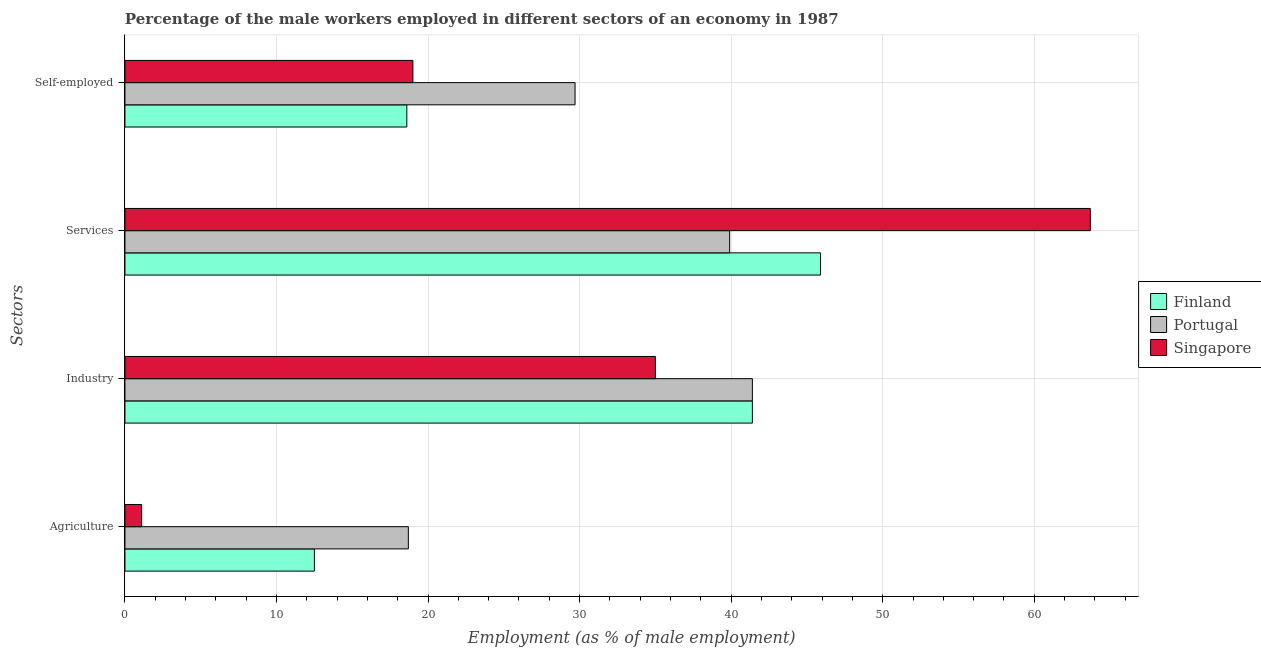Are the number of bars per tick equal to the number of legend labels?
Your answer should be compact. Yes. Are the number of bars on each tick of the Y-axis equal?
Offer a terse response. Yes. What is the label of the 4th group of bars from the top?
Keep it short and to the point. Agriculture. What is the percentage of male workers in agriculture in Portugal?
Your answer should be compact. 18.7. Across all countries, what is the maximum percentage of male workers in agriculture?
Offer a terse response. 18.7. Across all countries, what is the minimum percentage of male workers in services?
Offer a very short reply. 39.9. In which country was the percentage of self employed male workers maximum?
Ensure brevity in your answer.  Portugal. What is the total percentage of male workers in industry in the graph?
Give a very brief answer. 117.8. What is the difference between the percentage of male workers in industry in Finland and that in Portugal?
Your answer should be compact. 0. What is the difference between the percentage of male workers in industry in Singapore and the percentage of male workers in agriculture in Finland?
Your response must be concise. 22.5. What is the average percentage of self employed male workers per country?
Provide a succinct answer. 22.43. What is the difference between the percentage of male workers in agriculture and percentage of male workers in industry in Portugal?
Keep it short and to the point. -22.7. What is the ratio of the percentage of male workers in agriculture in Singapore to that in Portugal?
Your answer should be compact. 0.06. Is the percentage of self employed male workers in Finland less than that in Portugal?
Your answer should be very brief. Yes. What is the difference between the highest and the second highest percentage of male workers in industry?
Offer a very short reply. 0. What is the difference between the highest and the lowest percentage of male workers in industry?
Offer a terse response. 6.4. What does the 1st bar from the top in Self-employed represents?
Keep it short and to the point. Singapore. What does the 1st bar from the bottom in Services represents?
Make the answer very short. Finland. Is it the case that in every country, the sum of the percentage of male workers in agriculture and percentage of male workers in industry is greater than the percentage of male workers in services?
Your answer should be very brief. No. How many bars are there?
Offer a very short reply. 12. What is the difference between two consecutive major ticks on the X-axis?
Keep it short and to the point. 10. Are the values on the major ticks of X-axis written in scientific E-notation?
Your answer should be compact. No. How are the legend labels stacked?
Your answer should be very brief. Vertical. What is the title of the graph?
Give a very brief answer. Percentage of the male workers employed in different sectors of an economy in 1987. What is the label or title of the X-axis?
Offer a terse response. Employment (as % of male employment). What is the label or title of the Y-axis?
Your answer should be compact. Sectors. What is the Employment (as % of male employment) in Portugal in Agriculture?
Make the answer very short. 18.7. What is the Employment (as % of male employment) in Singapore in Agriculture?
Provide a succinct answer. 1.1. What is the Employment (as % of male employment) in Finland in Industry?
Offer a very short reply. 41.4. What is the Employment (as % of male employment) of Portugal in Industry?
Provide a short and direct response. 41.4. What is the Employment (as % of male employment) of Finland in Services?
Offer a terse response. 45.9. What is the Employment (as % of male employment) of Portugal in Services?
Give a very brief answer. 39.9. What is the Employment (as % of male employment) of Singapore in Services?
Your answer should be very brief. 63.7. What is the Employment (as % of male employment) of Finland in Self-employed?
Keep it short and to the point. 18.6. What is the Employment (as % of male employment) in Portugal in Self-employed?
Provide a short and direct response. 29.7. Across all Sectors, what is the maximum Employment (as % of male employment) in Finland?
Offer a terse response. 45.9. Across all Sectors, what is the maximum Employment (as % of male employment) of Portugal?
Provide a succinct answer. 41.4. Across all Sectors, what is the maximum Employment (as % of male employment) in Singapore?
Ensure brevity in your answer.  63.7. Across all Sectors, what is the minimum Employment (as % of male employment) of Portugal?
Make the answer very short. 18.7. Across all Sectors, what is the minimum Employment (as % of male employment) of Singapore?
Offer a terse response. 1.1. What is the total Employment (as % of male employment) of Finland in the graph?
Offer a very short reply. 118.4. What is the total Employment (as % of male employment) in Portugal in the graph?
Provide a short and direct response. 129.7. What is the total Employment (as % of male employment) of Singapore in the graph?
Ensure brevity in your answer.  118.8. What is the difference between the Employment (as % of male employment) of Finland in Agriculture and that in Industry?
Your answer should be compact. -28.9. What is the difference between the Employment (as % of male employment) of Portugal in Agriculture and that in Industry?
Ensure brevity in your answer.  -22.7. What is the difference between the Employment (as % of male employment) of Singapore in Agriculture and that in Industry?
Make the answer very short. -33.9. What is the difference between the Employment (as % of male employment) of Finland in Agriculture and that in Services?
Offer a very short reply. -33.4. What is the difference between the Employment (as % of male employment) of Portugal in Agriculture and that in Services?
Keep it short and to the point. -21.2. What is the difference between the Employment (as % of male employment) in Singapore in Agriculture and that in Services?
Provide a short and direct response. -62.6. What is the difference between the Employment (as % of male employment) of Finland in Agriculture and that in Self-employed?
Your response must be concise. -6.1. What is the difference between the Employment (as % of male employment) of Singapore in Agriculture and that in Self-employed?
Give a very brief answer. -17.9. What is the difference between the Employment (as % of male employment) of Singapore in Industry and that in Services?
Your answer should be very brief. -28.7. What is the difference between the Employment (as % of male employment) in Finland in Industry and that in Self-employed?
Your response must be concise. 22.8. What is the difference between the Employment (as % of male employment) of Singapore in Industry and that in Self-employed?
Keep it short and to the point. 16. What is the difference between the Employment (as % of male employment) of Finland in Services and that in Self-employed?
Offer a very short reply. 27.3. What is the difference between the Employment (as % of male employment) in Portugal in Services and that in Self-employed?
Your answer should be very brief. 10.2. What is the difference between the Employment (as % of male employment) in Singapore in Services and that in Self-employed?
Keep it short and to the point. 44.7. What is the difference between the Employment (as % of male employment) of Finland in Agriculture and the Employment (as % of male employment) of Portugal in Industry?
Make the answer very short. -28.9. What is the difference between the Employment (as % of male employment) in Finland in Agriculture and the Employment (as % of male employment) in Singapore in Industry?
Your response must be concise. -22.5. What is the difference between the Employment (as % of male employment) of Portugal in Agriculture and the Employment (as % of male employment) of Singapore in Industry?
Offer a very short reply. -16.3. What is the difference between the Employment (as % of male employment) in Finland in Agriculture and the Employment (as % of male employment) in Portugal in Services?
Provide a succinct answer. -27.4. What is the difference between the Employment (as % of male employment) in Finland in Agriculture and the Employment (as % of male employment) in Singapore in Services?
Keep it short and to the point. -51.2. What is the difference between the Employment (as % of male employment) in Portugal in Agriculture and the Employment (as % of male employment) in Singapore in Services?
Offer a very short reply. -45. What is the difference between the Employment (as % of male employment) in Finland in Agriculture and the Employment (as % of male employment) in Portugal in Self-employed?
Offer a very short reply. -17.2. What is the difference between the Employment (as % of male employment) in Finland in Industry and the Employment (as % of male employment) in Portugal in Services?
Your answer should be very brief. 1.5. What is the difference between the Employment (as % of male employment) in Finland in Industry and the Employment (as % of male employment) in Singapore in Services?
Your answer should be compact. -22.3. What is the difference between the Employment (as % of male employment) in Portugal in Industry and the Employment (as % of male employment) in Singapore in Services?
Give a very brief answer. -22.3. What is the difference between the Employment (as % of male employment) in Finland in Industry and the Employment (as % of male employment) in Singapore in Self-employed?
Ensure brevity in your answer.  22.4. What is the difference between the Employment (as % of male employment) of Portugal in Industry and the Employment (as % of male employment) of Singapore in Self-employed?
Provide a succinct answer. 22.4. What is the difference between the Employment (as % of male employment) in Finland in Services and the Employment (as % of male employment) in Singapore in Self-employed?
Ensure brevity in your answer.  26.9. What is the difference between the Employment (as % of male employment) in Portugal in Services and the Employment (as % of male employment) in Singapore in Self-employed?
Make the answer very short. 20.9. What is the average Employment (as % of male employment) in Finland per Sectors?
Provide a succinct answer. 29.6. What is the average Employment (as % of male employment) in Portugal per Sectors?
Your answer should be compact. 32.42. What is the average Employment (as % of male employment) of Singapore per Sectors?
Offer a terse response. 29.7. What is the difference between the Employment (as % of male employment) in Finland and Employment (as % of male employment) in Portugal in Agriculture?
Your answer should be very brief. -6.2. What is the difference between the Employment (as % of male employment) in Finland and Employment (as % of male employment) in Singapore in Agriculture?
Provide a short and direct response. 11.4. What is the difference between the Employment (as % of male employment) in Portugal and Employment (as % of male employment) in Singapore in Agriculture?
Ensure brevity in your answer.  17.6. What is the difference between the Employment (as % of male employment) of Finland and Employment (as % of male employment) of Portugal in Industry?
Make the answer very short. 0. What is the difference between the Employment (as % of male employment) in Portugal and Employment (as % of male employment) in Singapore in Industry?
Keep it short and to the point. 6.4. What is the difference between the Employment (as % of male employment) in Finland and Employment (as % of male employment) in Singapore in Services?
Keep it short and to the point. -17.8. What is the difference between the Employment (as % of male employment) in Portugal and Employment (as % of male employment) in Singapore in Services?
Offer a very short reply. -23.8. What is the difference between the Employment (as % of male employment) in Finland and Employment (as % of male employment) in Portugal in Self-employed?
Ensure brevity in your answer.  -11.1. What is the difference between the Employment (as % of male employment) in Finland and Employment (as % of male employment) in Singapore in Self-employed?
Ensure brevity in your answer.  -0.4. What is the ratio of the Employment (as % of male employment) of Finland in Agriculture to that in Industry?
Ensure brevity in your answer.  0.3. What is the ratio of the Employment (as % of male employment) in Portugal in Agriculture to that in Industry?
Provide a succinct answer. 0.45. What is the ratio of the Employment (as % of male employment) in Singapore in Agriculture to that in Industry?
Ensure brevity in your answer.  0.03. What is the ratio of the Employment (as % of male employment) of Finland in Agriculture to that in Services?
Your answer should be compact. 0.27. What is the ratio of the Employment (as % of male employment) of Portugal in Agriculture to that in Services?
Ensure brevity in your answer.  0.47. What is the ratio of the Employment (as % of male employment) of Singapore in Agriculture to that in Services?
Keep it short and to the point. 0.02. What is the ratio of the Employment (as % of male employment) of Finland in Agriculture to that in Self-employed?
Ensure brevity in your answer.  0.67. What is the ratio of the Employment (as % of male employment) of Portugal in Agriculture to that in Self-employed?
Offer a terse response. 0.63. What is the ratio of the Employment (as % of male employment) of Singapore in Agriculture to that in Self-employed?
Provide a succinct answer. 0.06. What is the ratio of the Employment (as % of male employment) of Finland in Industry to that in Services?
Your response must be concise. 0.9. What is the ratio of the Employment (as % of male employment) of Portugal in Industry to that in Services?
Provide a succinct answer. 1.04. What is the ratio of the Employment (as % of male employment) of Singapore in Industry to that in Services?
Your answer should be very brief. 0.55. What is the ratio of the Employment (as % of male employment) of Finland in Industry to that in Self-employed?
Provide a short and direct response. 2.23. What is the ratio of the Employment (as % of male employment) of Portugal in Industry to that in Self-employed?
Keep it short and to the point. 1.39. What is the ratio of the Employment (as % of male employment) of Singapore in Industry to that in Self-employed?
Give a very brief answer. 1.84. What is the ratio of the Employment (as % of male employment) of Finland in Services to that in Self-employed?
Ensure brevity in your answer.  2.47. What is the ratio of the Employment (as % of male employment) of Portugal in Services to that in Self-employed?
Offer a very short reply. 1.34. What is the ratio of the Employment (as % of male employment) in Singapore in Services to that in Self-employed?
Give a very brief answer. 3.35. What is the difference between the highest and the second highest Employment (as % of male employment) of Finland?
Keep it short and to the point. 4.5. What is the difference between the highest and the second highest Employment (as % of male employment) in Portugal?
Offer a very short reply. 1.5. What is the difference between the highest and the second highest Employment (as % of male employment) in Singapore?
Provide a short and direct response. 28.7. What is the difference between the highest and the lowest Employment (as % of male employment) in Finland?
Provide a short and direct response. 33.4. What is the difference between the highest and the lowest Employment (as % of male employment) of Portugal?
Give a very brief answer. 22.7. What is the difference between the highest and the lowest Employment (as % of male employment) in Singapore?
Give a very brief answer. 62.6. 